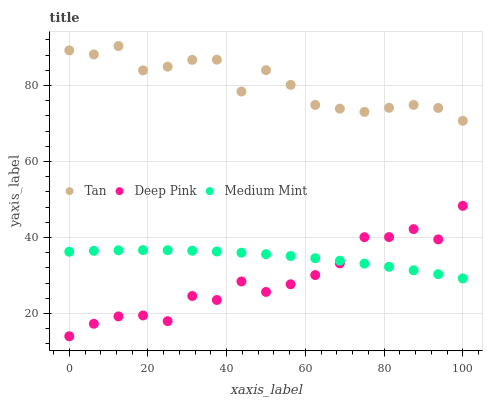Does Deep Pink have the minimum area under the curve?
Answer yes or no. Yes. Does Tan have the maximum area under the curve?
Answer yes or no. Yes. Does Tan have the minimum area under the curve?
Answer yes or no. No. Does Deep Pink have the maximum area under the curve?
Answer yes or no. No. Is Medium Mint the smoothest?
Answer yes or no. Yes. Is Deep Pink the roughest?
Answer yes or no. Yes. Is Tan the smoothest?
Answer yes or no. No. Is Tan the roughest?
Answer yes or no. No. Does Deep Pink have the lowest value?
Answer yes or no. Yes. Does Tan have the lowest value?
Answer yes or no. No. Does Tan have the highest value?
Answer yes or no. Yes. Does Deep Pink have the highest value?
Answer yes or no. No. Is Medium Mint less than Tan?
Answer yes or no. Yes. Is Tan greater than Deep Pink?
Answer yes or no. Yes. Does Medium Mint intersect Deep Pink?
Answer yes or no. Yes. Is Medium Mint less than Deep Pink?
Answer yes or no. No. Is Medium Mint greater than Deep Pink?
Answer yes or no. No. Does Medium Mint intersect Tan?
Answer yes or no. No. 